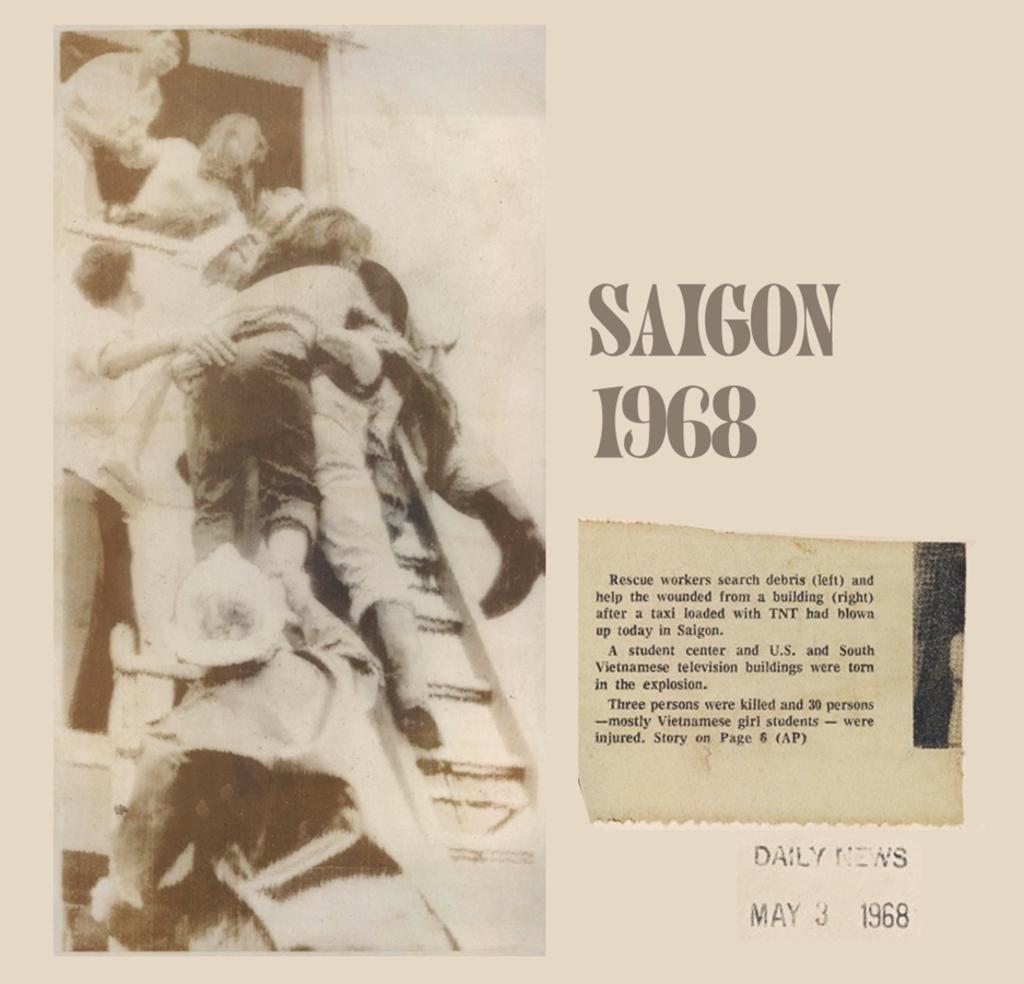Could you give a brief overview of what you see in this image? In this image, we can see a poster, on that poster we can see some text printed on it. 